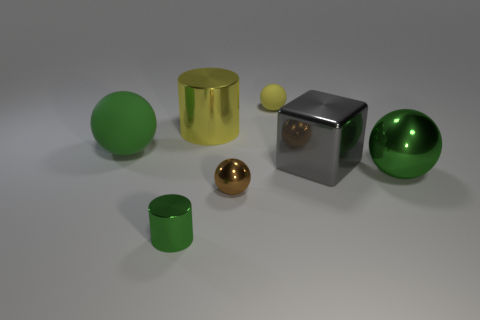Subtract all tiny yellow rubber spheres. How many spheres are left? 3 Add 3 small metal balls. How many objects exist? 10 Subtract all balls. How many objects are left? 3 Subtract all green balls. How many balls are left? 2 Add 3 tiny yellow rubber balls. How many tiny yellow rubber balls exist? 4 Subtract 0 red cylinders. How many objects are left? 7 Subtract 3 balls. How many balls are left? 1 Subtract all green cubes. Subtract all cyan spheres. How many cubes are left? 1 Subtract all cyan cubes. How many yellow spheres are left? 1 Subtract all gray metallic objects. Subtract all cyan objects. How many objects are left? 6 